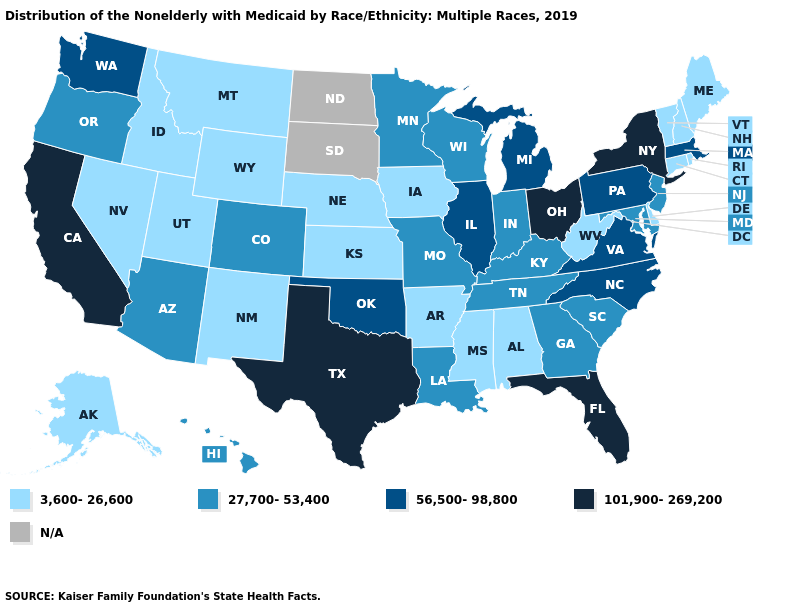What is the lowest value in the MidWest?
Give a very brief answer. 3,600-26,600. What is the value of Texas?
Short answer required. 101,900-269,200. What is the value of Hawaii?
Give a very brief answer. 27,700-53,400. What is the lowest value in the USA?
Keep it brief. 3,600-26,600. Which states have the lowest value in the USA?
Answer briefly. Alabama, Alaska, Arkansas, Connecticut, Delaware, Idaho, Iowa, Kansas, Maine, Mississippi, Montana, Nebraska, Nevada, New Hampshire, New Mexico, Rhode Island, Utah, Vermont, West Virginia, Wyoming. Name the states that have a value in the range N/A?
Short answer required. North Dakota, South Dakota. Does Nevada have the lowest value in the USA?
Short answer required. Yes. Which states hav the highest value in the Northeast?
Concise answer only. New York. What is the value of Nebraska?
Concise answer only. 3,600-26,600. Name the states that have a value in the range N/A?
Be succinct. North Dakota, South Dakota. What is the lowest value in the MidWest?
Keep it brief. 3,600-26,600. Does Texas have the highest value in the South?
Write a very short answer. Yes. Among the states that border New York , which have the highest value?
Write a very short answer. Massachusetts, Pennsylvania. 